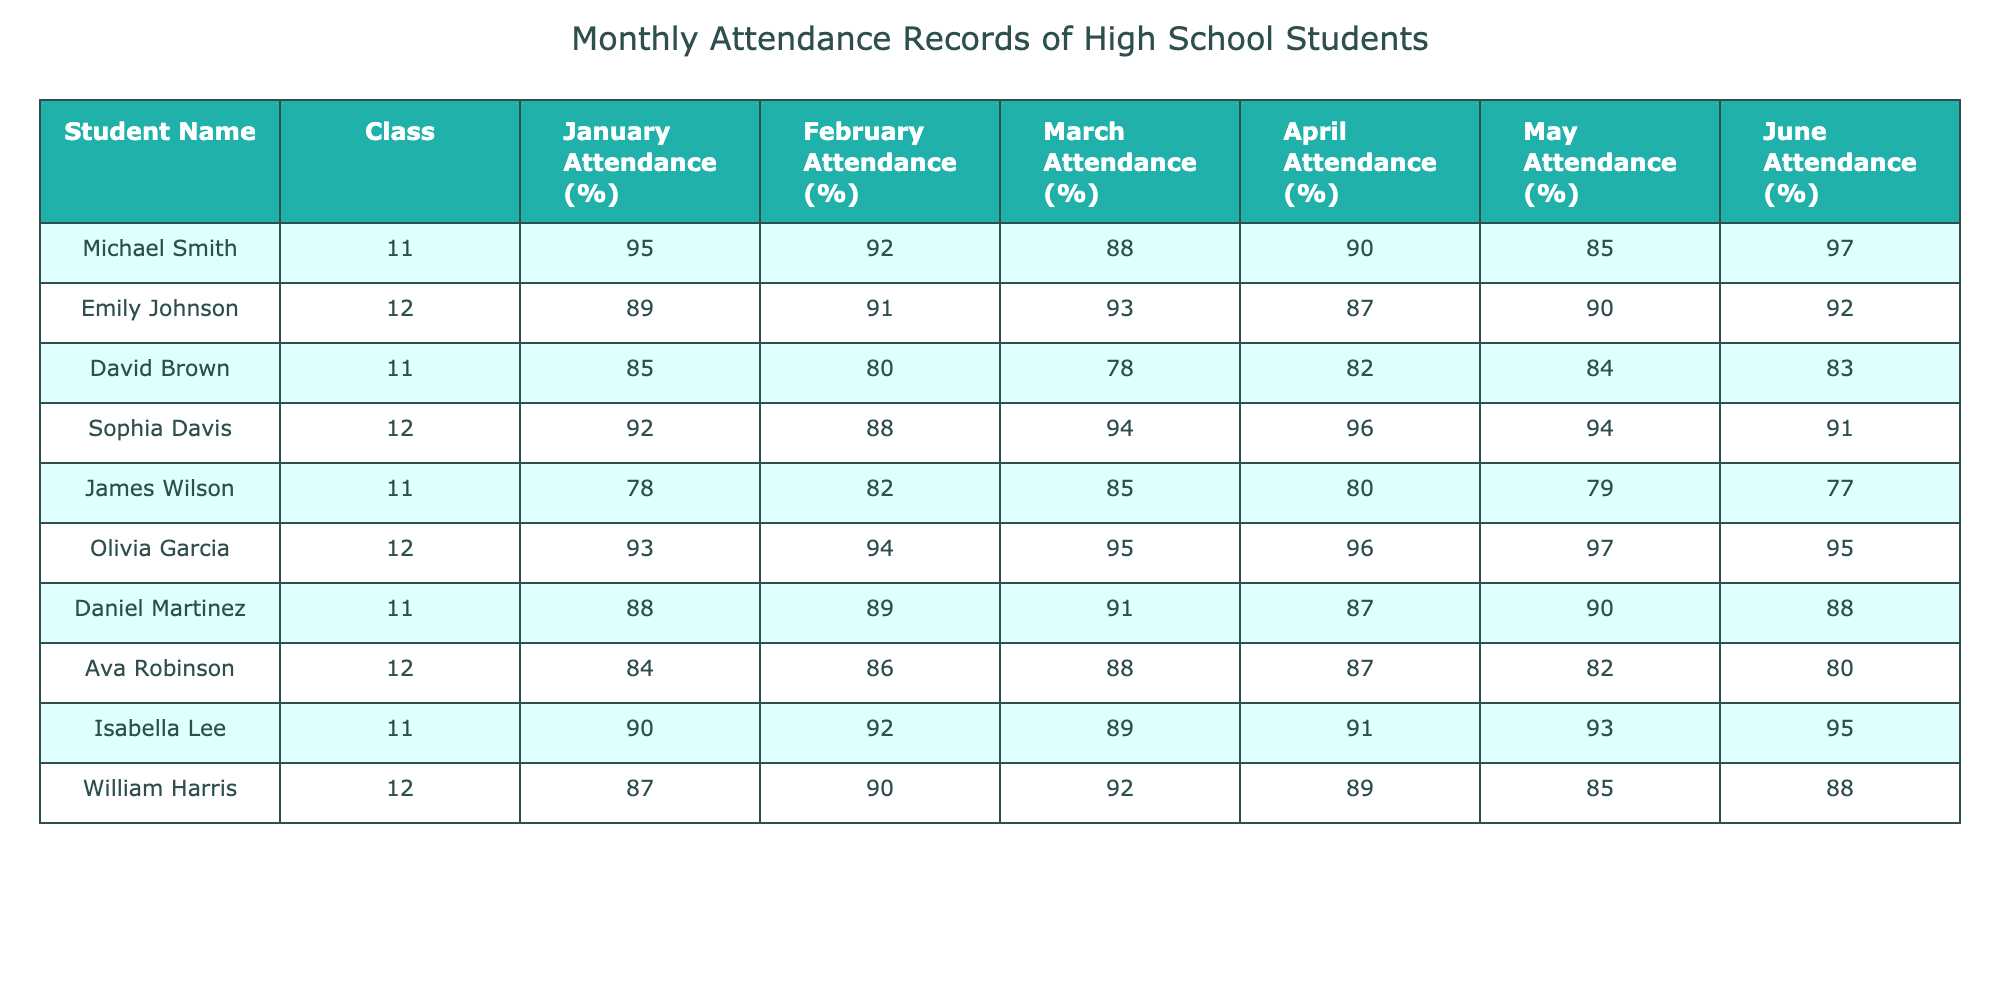What is the highest attendance percentage in January? In January, the highest attendance percentage is from Michael Smith with 95%. Looking through the January attendance column, I check each student's percentage, and Michael's is the highest.
Answer: 95% Who had the lowest attendance in June? In June, the lowest attendance percentage is from James Wilson with 77%. By examining the June attendance column, I compare all values, and I find that James has the smallest percentage.
Answer: 77% What is the average attendance percentage for David Brown across all months? To find David Brown's average attendance, I sum his percentages across all months: (85 + 80 + 78 + 82 + 84 + 83) = 492. Then, I divide by 6 (the number of months): 492 / 6 = 82.
Answer: 82 Did Olivia Garcia maintain an attendance percentage above 90% for all months? I check Olivia's attendance percentages month by month: January (93), February (94), March (95), April (96), May (97), June (95). Since all values are greater than 90%, the answer is yes.
Answer: Yes Who improved their attendance from January to April the most? I calculate the attendance change for each student from January to April by subtracting January attendance from April attendance. The highest improvement is from Michael Smith, who improved from 95% to 90% and had a decrease of 5%. However, other students also show decreases. I find that no student improved in this period based on the values provided.
Answer: No student improved Which class had better overall attendance in March? I sum the attendance percentages for 11th and 12th graders separately for March. For 11th graders: (88 + 78 + 85) = 251. For 12th graders: (93 + 94) = 187. Therefore, the 11th grade had a better average with 251.
Answer: 11th grade What percentage did Sophia Davis have in April? I look directly at Sophia's attendance in the April column, which shows her percentage as 96%. This is a direct lookup from the table for her specific month.
Answer: 96% What is the difference in attendance percentage between the highest and lowest attendance in May? To find the difference, I first identify the highest in May, which is Olivia Garcia at 97%, and the lowest, which is James Wilson at 85%. The difference is 97 - 85 = 12.
Answer: 12 